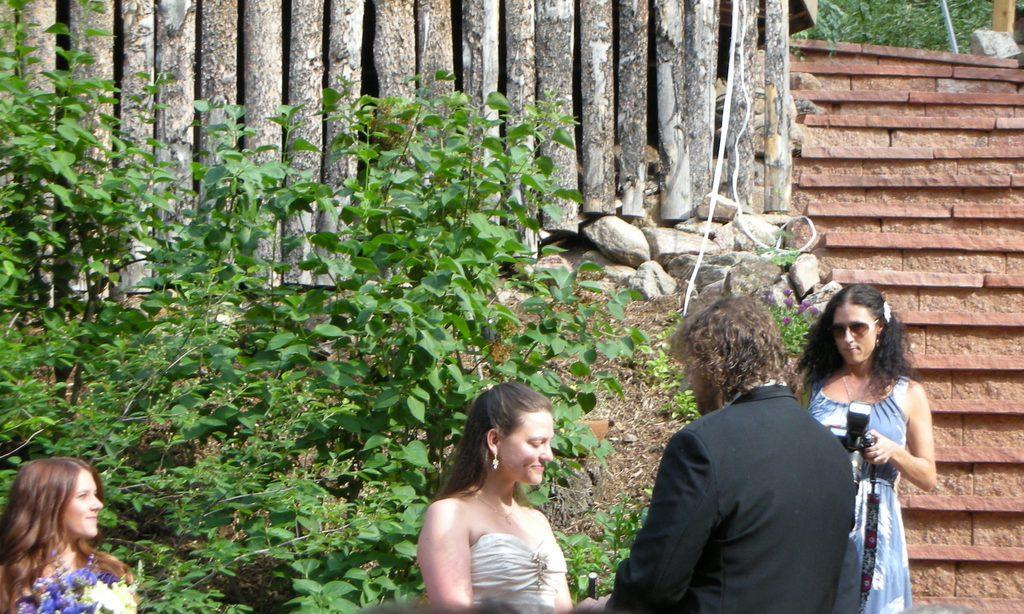Describe this image in one or two sentences. This is completely an outdoor picture. This is a wall. Here we can see the bamboo sticks. These are the plants. Here we can see three persons. These two women are holding a pretty smile on their faces. At the left side we can see on women is holding flower bouquet in her hands. At the right side of the picture a woman in gorgeous blue dress holding a camera in her hand. 